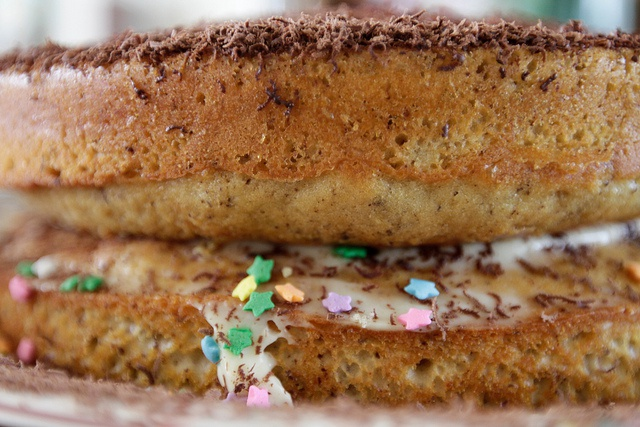Describe the objects in this image and their specific colors. I can see a cake in brown, gray, tan, maroon, and white tones in this image. 